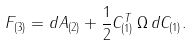<formula> <loc_0><loc_0><loc_500><loc_500>F _ { ( 3 ) } = d A _ { ( 2 ) } + \frac { 1 } { 2 } C _ { ( 1 ) } ^ { T } \, \Omega \, d C _ { ( 1 ) } .</formula> 